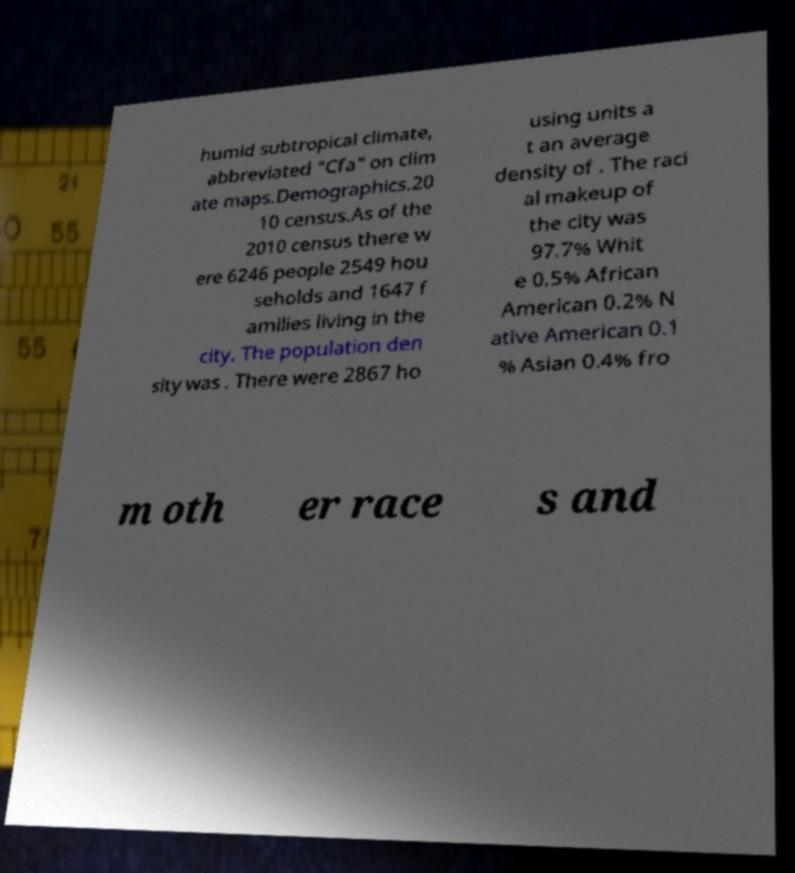There's text embedded in this image that I need extracted. Can you transcribe it verbatim? humid subtropical climate, abbreviated "Cfa" on clim ate maps.Demographics.20 10 census.As of the 2010 census there w ere 6246 people 2549 hou seholds and 1647 f amilies living in the city. The population den sity was . There were 2867 ho using units a t an average density of . The raci al makeup of the city was 97.7% Whit e 0.5% African American 0.2% N ative American 0.1 % Asian 0.4% fro m oth er race s and 